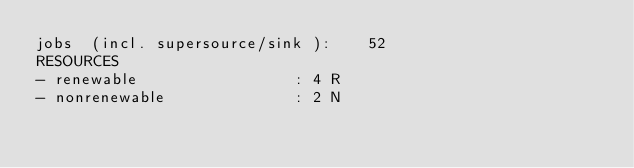Convert code to text. <code><loc_0><loc_0><loc_500><loc_500><_ObjectiveC_>jobs  (incl. supersource/sink ):	52
RESOURCES
- renewable                 : 4 R
- nonrenewable              : 2 N</code> 